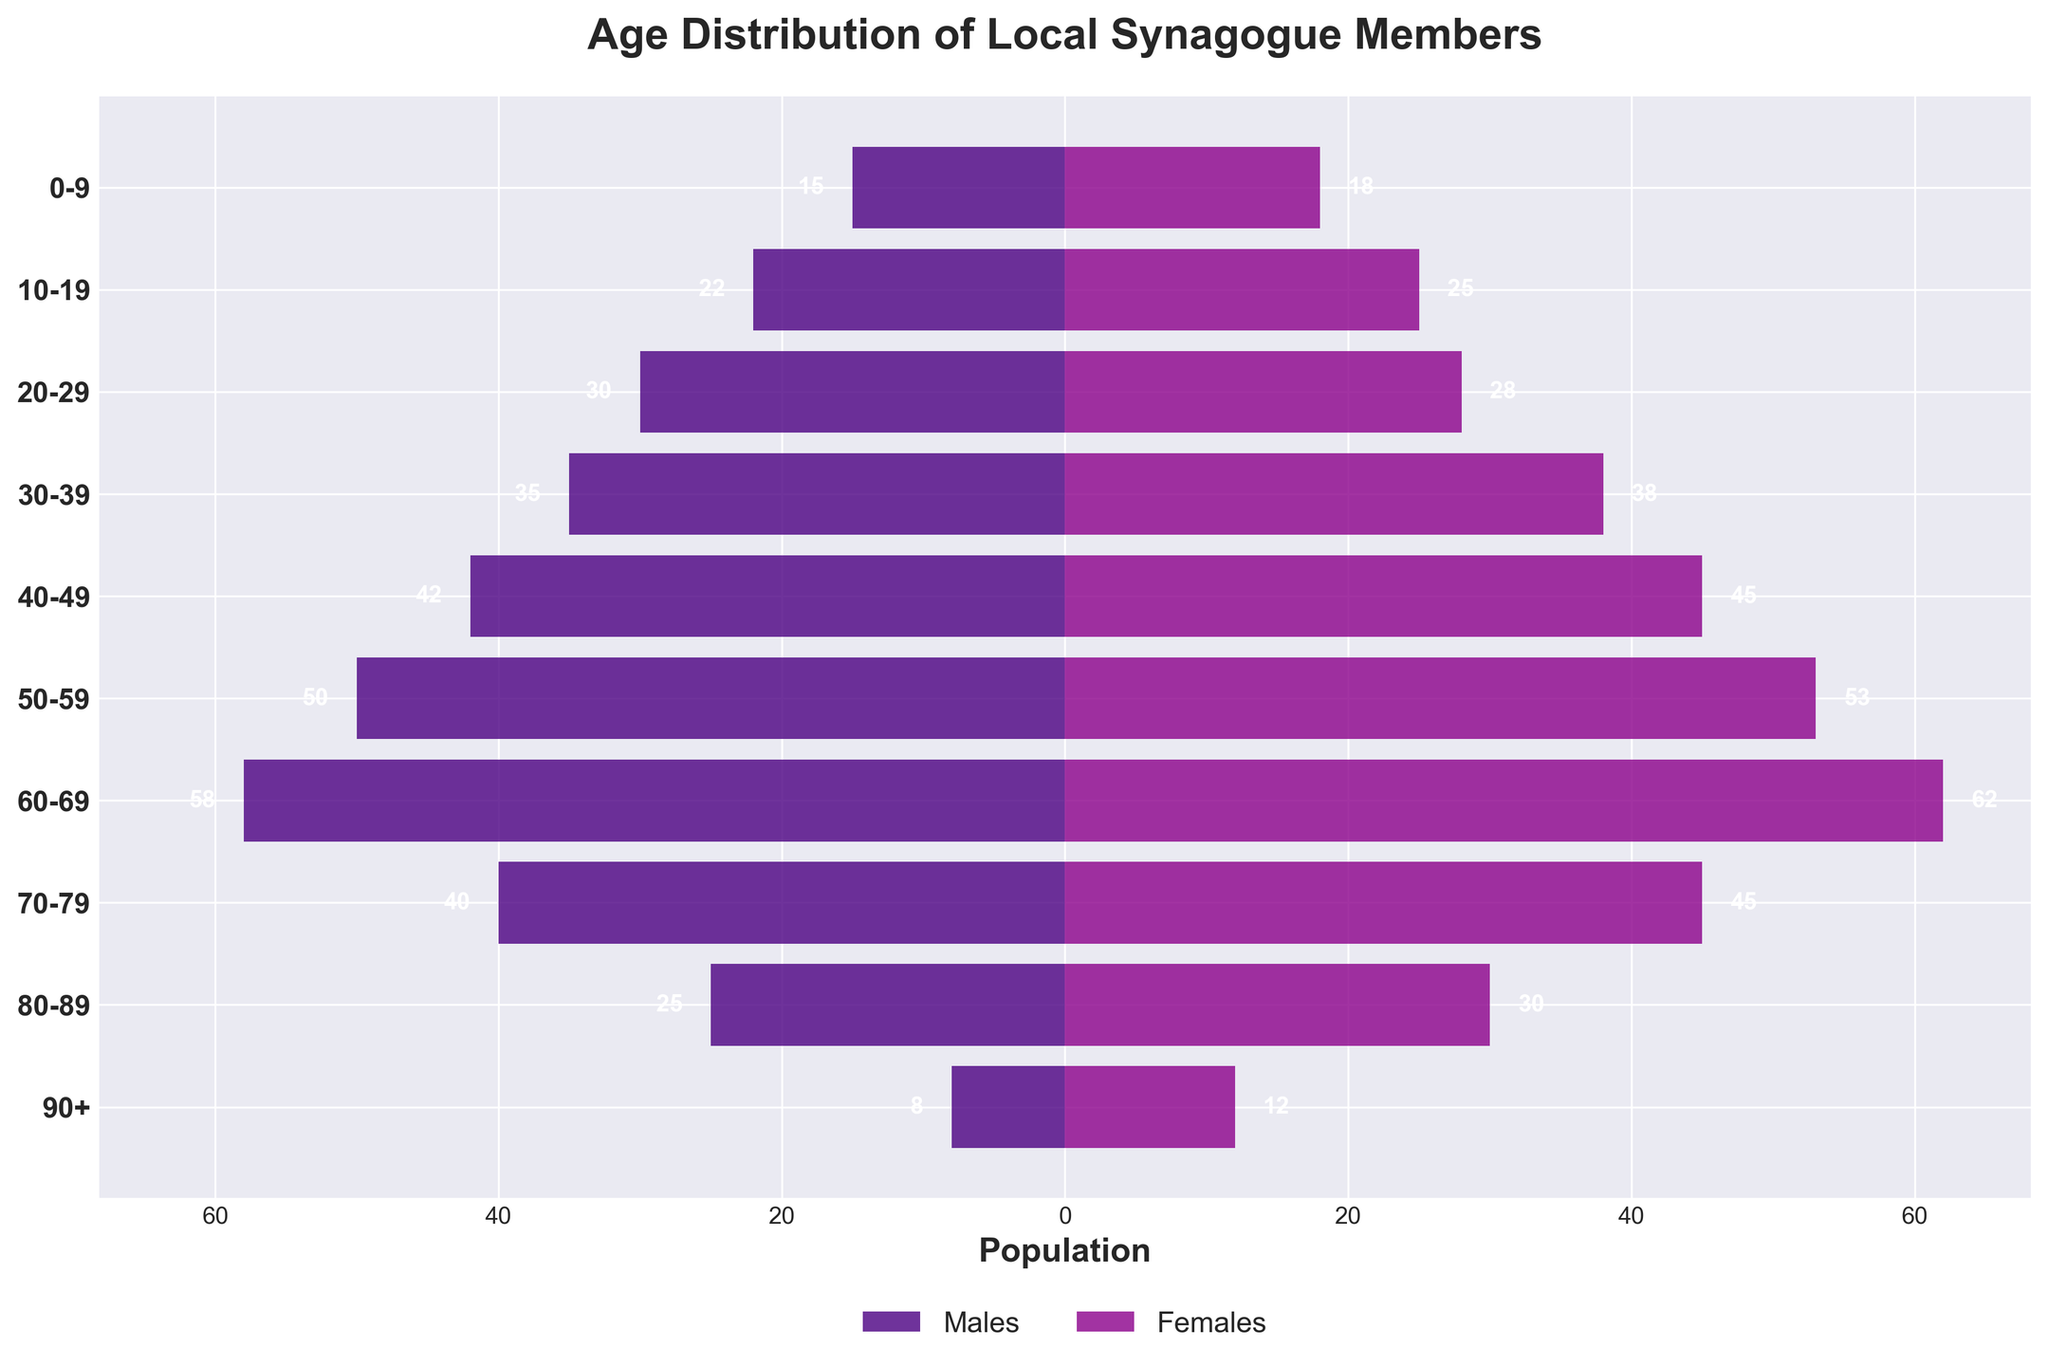What is the title of the figure? The title is displayed at the top of the figure.
Answer: Age Distribution of Local Synagogue Members What are the two colors used in the bars representing males and females? The figure uses two distinct colors; one for males and another for females.
Answer: Males: Purple, Females: Magenta Which age group has the highest number of female members? Identify the tallest bar on the right side (Females) of the figure.
Answer: 60-69 How many male and female members are in the 70-79 age group combined? Find the absolute values of the male and female bars for the 70-79 age group and add them together: 40 (males) + 45 (females) = 85.
Answer: 85 Which gender has more members in the 30-39 age group and by how many? Compare the lengths of the bars for males and females in the 30-39 age group and calculate the difference: 38 (females) - 35 (males) = 3 more females.
Answer: Females by 3 What age group has the lowest number of total members, and how many members does it have in total? Identify the shortest bars for both males and females combined and sum their absolute values: 8 (males) + 12 (females) = 20. This is for the 90+ age group.
Answer: 90+, 20 members How does the number of female members in the 20-29 age group compare to the number of male members in the same age group? Compare the lengths of the male and female bars for the 20-29 age group: 30 (males) vs. 28 (females).
Answer: Males have 2 more members What is the difference between the youngest and oldest age groups in terms of male members? Subtract the number of male members in the 90+ age group from the 0-9 age group: 15 (0-9) - 8 (90+) = 7.
Answer: 7 In which age group is the total number of male members the highest, and how many males are there in that group? Identify the longest male bar and check its corresponding age group: 60-69 with 58 members.
Answer: 60-69, 58 members How many more females are there than males in the 80-89 age group? Subtract the number of males from females in the 80-89 age group: 30 (females) - 25 (males) = 5.
Answer: 5 